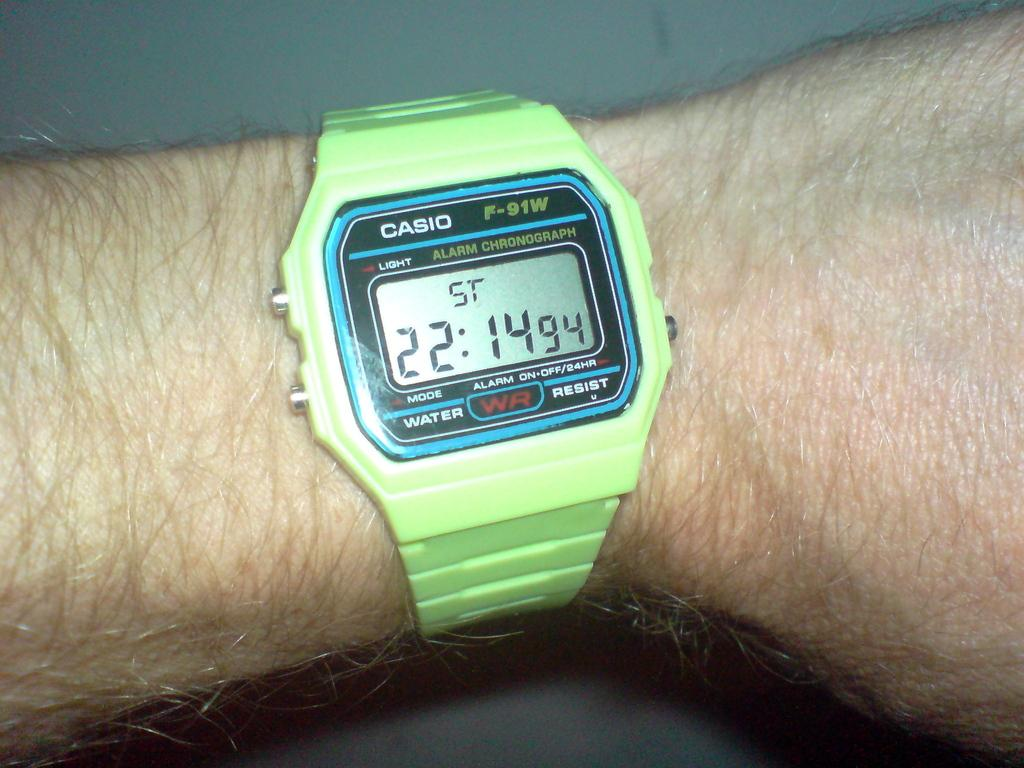<image>
Present a compact description of the photo's key features. A green Casio F-91W watch on a man's wrist. 